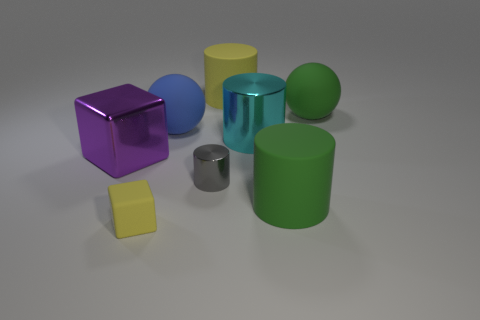There is a metal object that is the same size as the purple block; what shape is it?
Ensure brevity in your answer.  Cylinder. What number of things are rubber spheres to the left of the large green ball or things behind the small yellow rubber object?
Keep it short and to the point. 7. There is a cyan object that is the same size as the purple metallic thing; what is it made of?
Make the answer very short. Metal. What number of other things are there of the same material as the green ball
Offer a very short reply. 4. Is the number of objects in front of the matte cube the same as the number of big metal objects that are behind the big cyan metallic object?
Offer a very short reply. Yes. There is a big block; does it have the same color as the matte object behind the big green rubber sphere?
Provide a short and direct response. No. What number of large cylinders are on the right side of the large rubber cylinder behind the metal block behind the small yellow block?
Make the answer very short. 2. There is a green matte thing in front of the cyan shiny thing; what size is it?
Provide a succinct answer. Large. Is the shape of the yellow matte object behind the gray shiny object the same as  the tiny shiny thing?
Make the answer very short. Yes. There is a yellow thing that is the same shape as the large purple thing; what material is it?
Make the answer very short. Rubber. 